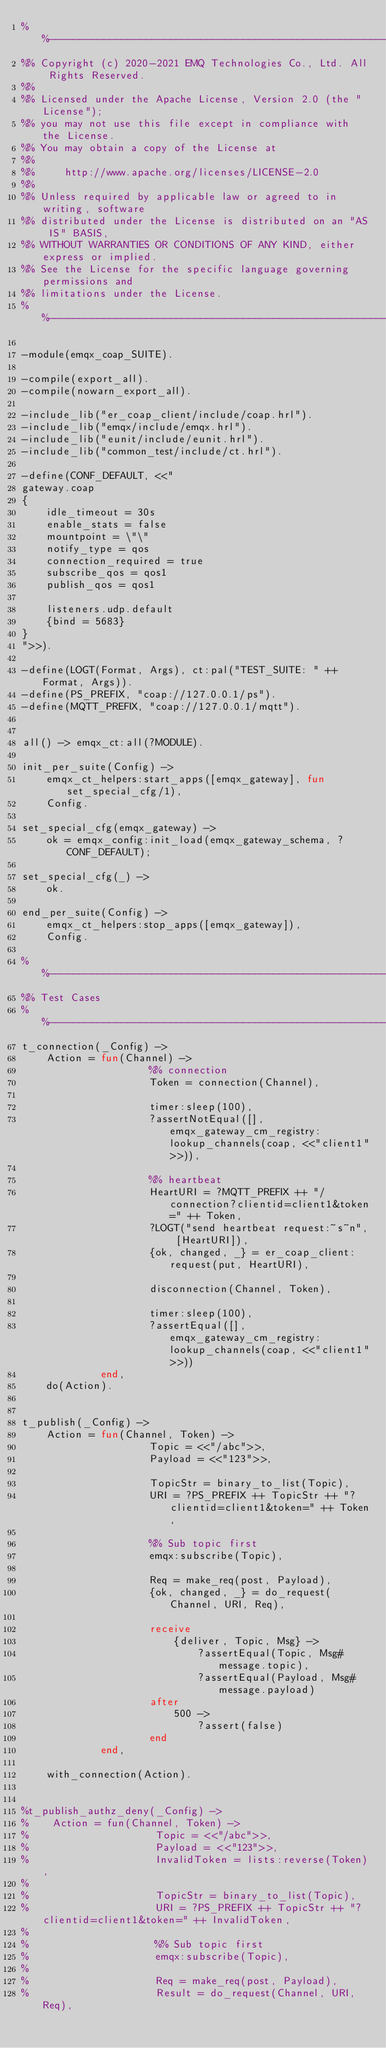Convert code to text. <code><loc_0><loc_0><loc_500><loc_500><_Erlang_>%%--------------------------------------------------------------------
%% Copyright (c) 2020-2021 EMQ Technologies Co., Ltd. All Rights Reserved.
%%
%% Licensed under the Apache License, Version 2.0 (the "License");
%% you may not use this file except in compliance with the License.
%% You may obtain a copy of the License at
%%
%%     http://www.apache.org/licenses/LICENSE-2.0
%%
%% Unless required by applicable law or agreed to in writing, software
%% distributed under the License is distributed on an "AS IS" BASIS,
%% WITHOUT WARRANTIES OR CONDITIONS OF ANY KIND, either express or implied.
%% See the License for the specific language governing permissions and
%% limitations under the License.
%%--------------------------------------------------------------------

-module(emqx_coap_SUITE).

-compile(export_all).
-compile(nowarn_export_all).

-include_lib("er_coap_client/include/coap.hrl").
-include_lib("emqx/include/emqx.hrl").
-include_lib("eunit/include/eunit.hrl").
-include_lib("common_test/include/ct.hrl").

-define(CONF_DEFAULT, <<"
gateway.coap
{
    idle_timeout = 30s
    enable_stats = false
    mountpoint = \"\"
    notify_type = qos
    connection_required = true
    subscribe_qos = qos1
    publish_qos = qos1

    listeners.udp.default
    {bind = 5683}
}
">>).

-define(LOGT(Format, Args), ct:pal("TEST_SUITE: " ++ Format, Args)).
-define(PS_PREFIX, "coap://127.0.0.1/ps").
-define(MQTT_PREFIX, "coap://127.0.0.1/mqtt").


all() -> emqx_ct:all(?MODULE).

init_per_suite(Config) ->
    emqx_ct_helpers:start_apps([emqx_gateway], fun set_special_cfg/1),
    Config.

set_special_cfg(emqx_gateway) ->
    ok = emqx_config:init_load(emqx_gateway_schema, ?CONF_DEFAULT);

set_special_cfg(_) ->
    ok.

end_per_suite(Config) ->
    emqx_ct_helpers:stop_apps([emqx_gateway]),
    Config.

%%--------------------------------------------------------------------
%% Test Cases
%%--------------------------------------------------------------------
t_connection(_Config) ->
    Action = fun(Channel) ->
                     %% connection
                     Token = connection(Channel),

                     timer:sleep(100),
                     ?assertNotEqual([], emqx_gateway_cm_registry:lookup_channels(coap, <<"client1">>)),

                     %% heartbeat
                     HeartURI = ?MQTT_PREFIX ++ "/connection?clientid=client1&token=" ++ Token,
                     ?LOGT("send heartbeat request:~s~n", [HeartURI]),
                     {ok, changed, _} = er_coap_client:request(put, HeartURI),

                     disconnection(Channel, Token),

                     timer:sleep(100),
                     ?assertEqual([], emqx_gateway_cm_registry:lookup_channels(coap, <<"client1">>))
             end,
    do(Action).


t_publish(_Config) ->
    Action = fun(Channel, Token) ->
                     Topic = <<"/abc">>,
                     Payload = <<"123">>,

                     TopicStr = binary_to_list(Topic),
                     URI = ?PS_PREFIX ++ TopicStr ++ "?clientid=client1&token=" ++ Token,

                     %% Sub topic first
                     emqx:subscribe(Topic),

                     Req = make_req(post, Payload),
                     {ok, changed, _} = do_request(Channel, URI, Req),

                     receive
                         {deliver, Topic, Msg} ->
                             ?assertEqual(Topic, Msg#message.topic),
                             ?assertEqual(Payload, Msg#message.payload)
                     after
                         500 ->
                             ?assert(false)
                     end
             end,

    with_connection(Action).


%t_publish_authz_deny(_Config) ->
%    Action = fun(Channel, Token) ->
%                     Topic = <<"/abc">>,
%                     Payload = <<"123">>,
%                     InvalidToken = lists:reverse(Token),
%
%                     TopicStr = binary_to_list(Topic),
%                     URI = ?PS_PREFIX ++ TopicStr ++ "?clientid=client1&token=" ++ InvalidToken,
%
%                     %% Sub topic first
%                     emqx:subscribe(Topic),
%
%                     Req = make_req(post, Payload),
%                     Result = do_request(Channel, URI, Req),</code> 